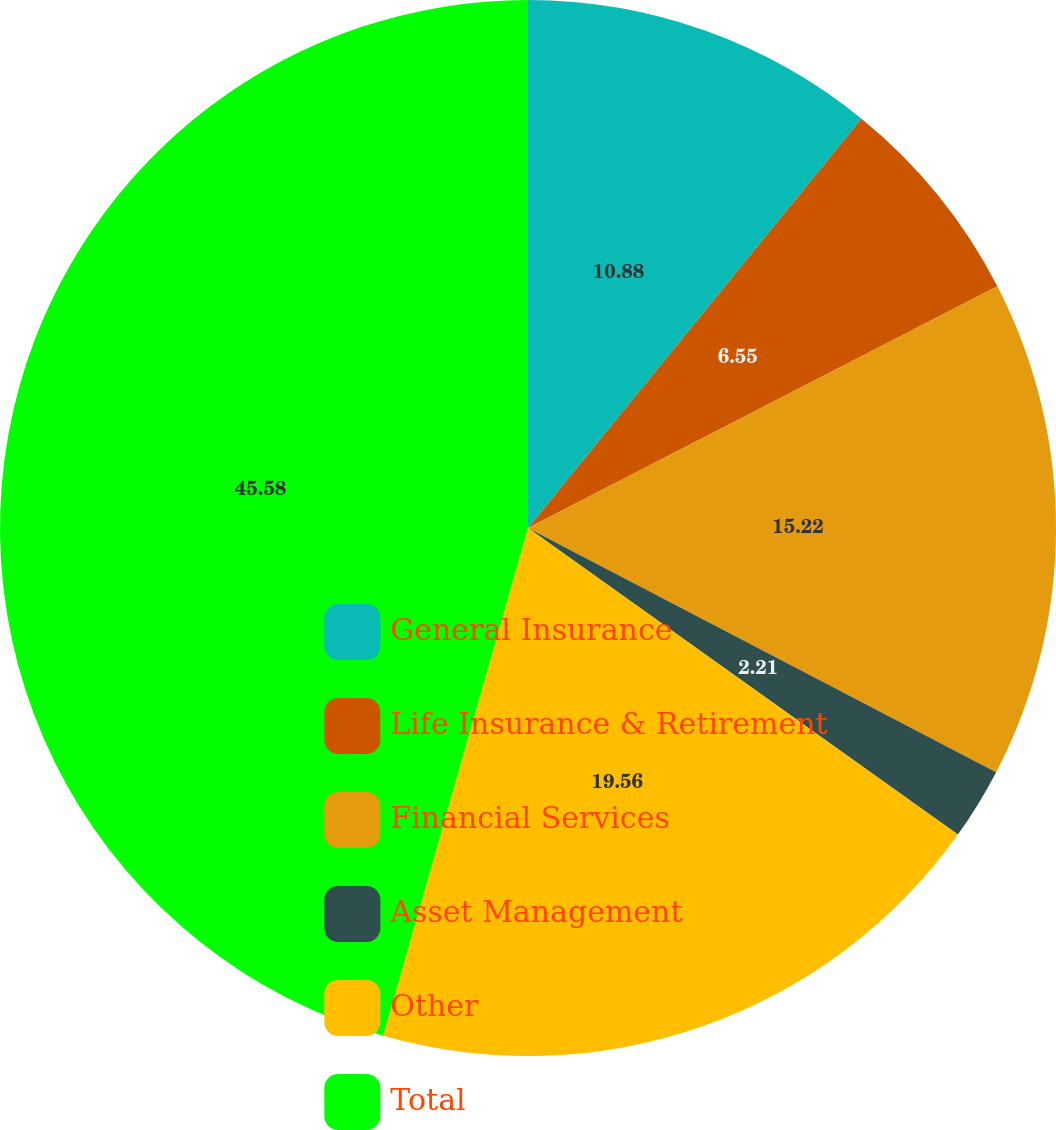Convert chart. <chart><loc_0><loc_0><loc_500><loc_500><pie_chart><fcel>General Insurance<fcel>Life Insurance & Retirement<fcel>Financial Services<fcel>Asset Management<fcel>Other<fcel>Total<nl><fcel>10.88%<fcel>6.55%<fcel>15.22%<fcel>2.21%<fcel>19.56%<fcel>45.58%<nl></chart> 